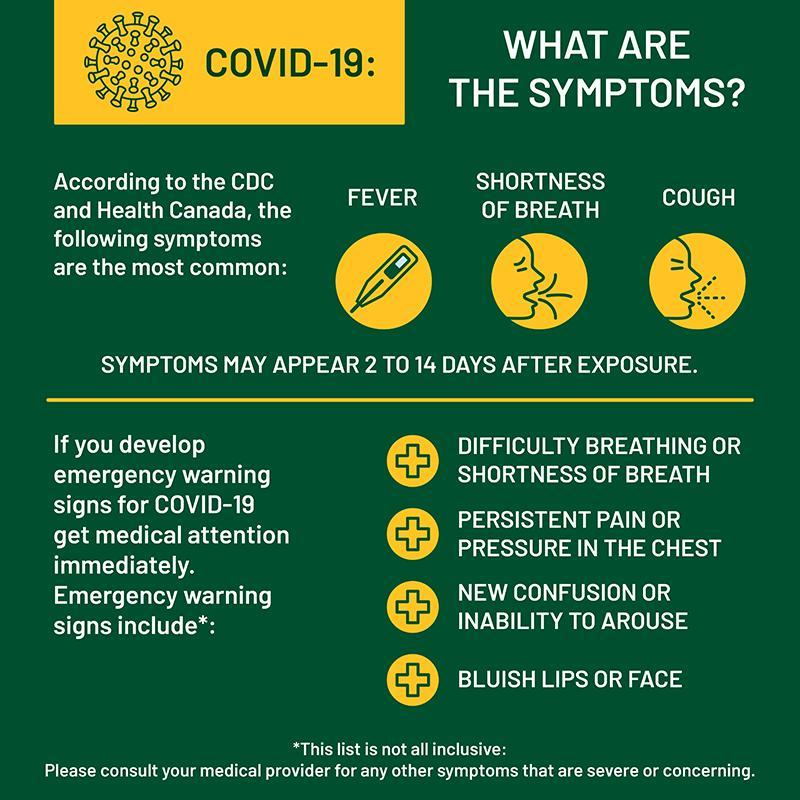What are the symptoms of COVID-19 other than fever & cough?
Answer the question with a short phrase. SHORTNESS OF BREATH What is the incubation period of the COVID-19 virus? 2 to 14 DAYS 